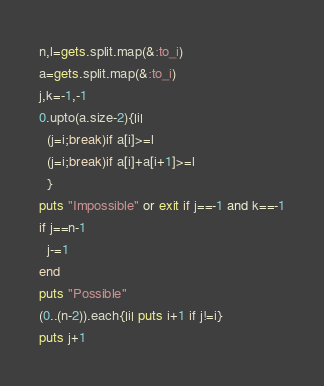<code> <loc_0><loc_0><loc_500><loc_500><_Ruby_>n,l=gets.split.map(&:to_i)
a=gets.split.map(&:to_i)
j,k=-1,-1
0.upto(a.size-2){|i|
  (j=i;break)if a[i]>=l
  (j=i;break)if a[i]+a[i+1]>=l
  }
puts "Impossible" or exit if j==-1 and k==-1
if j==n-1
  j-=1
end
puts "Possible"
(0..(n-2)).each{|i| puts i+1 if j!=i}
puts j+1</code> 